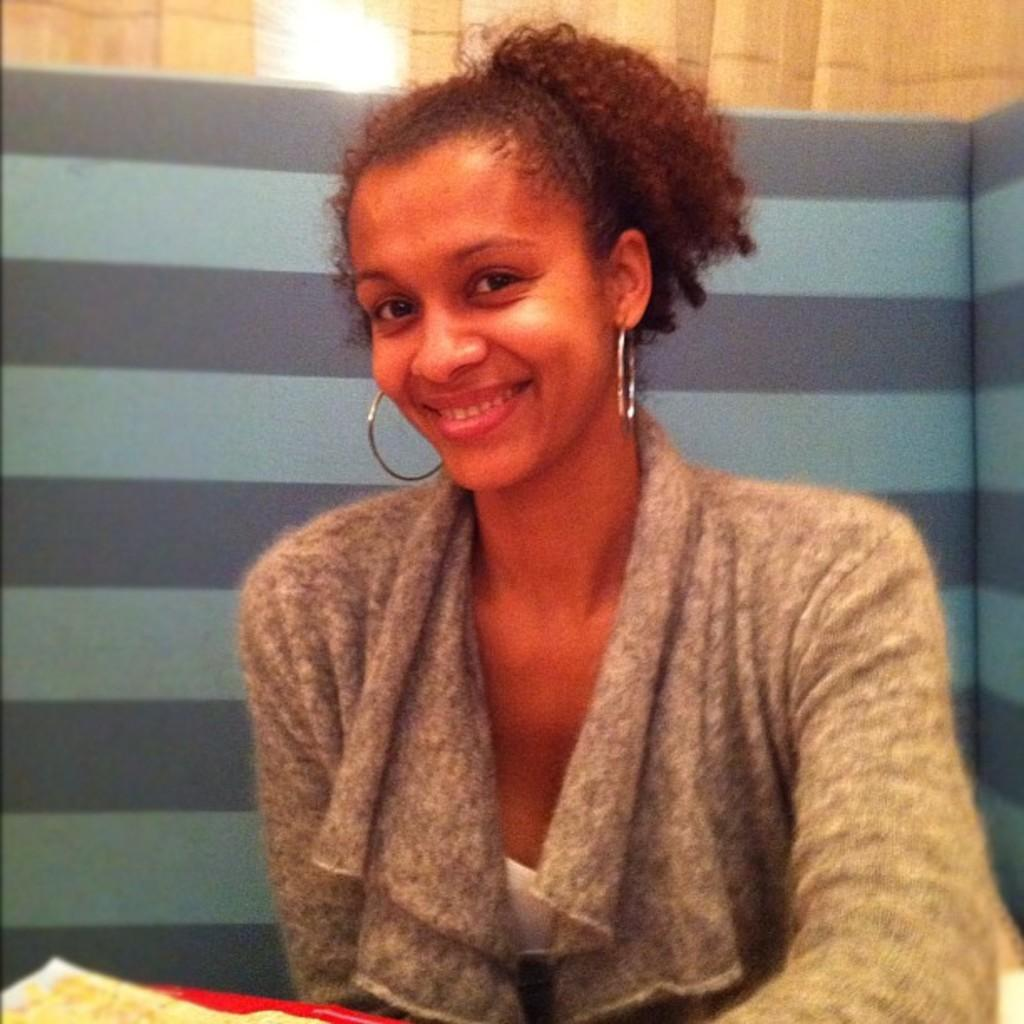Who is present in the image? There is a woman in the image. What is the woman's facial expression? The woman is smiling. What can be seen in front of the woman? There are objects in front of the woman. What is located behind the woman? There is a board and a curtain behind the woman. What type of straw is the woman using to brush her teeth in the image? There is no straw or toothbrush present in the image. What liquid is the woman drinking in the image? There is no liquid or drinking activity depicted in the image. 